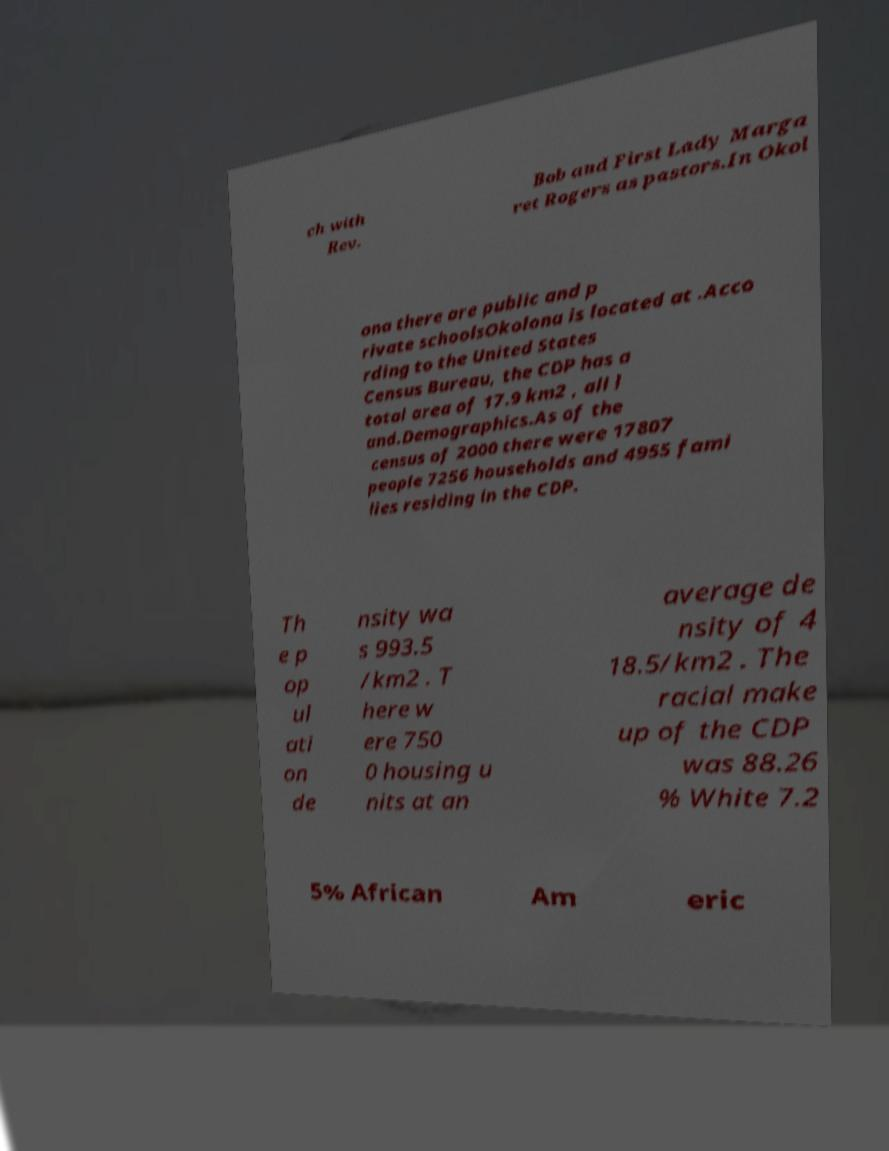Please identify and transcribe the text found in this image. ch with Rev. Bob and First Lady Marga ret Rogers as pastors.In Okol ona there are public and p rivate schoolsOkolona is located at .Acco rding to the United States Census Bureau, the CDP has a total area of 17.9 km2 , all l and.Demographics.As of the census of 2000 there were 17807 people 7256 households and 4955 fami lies residing in the CDP. Th e p op ul ati on de nsity wa s 993.5 /km2 . T here w ere 750 0 housing u nits at an average de nsity of 4 18.5/km2 . The racial make up of the CDP was 88.26 % White 7.2 5% African Am eric 